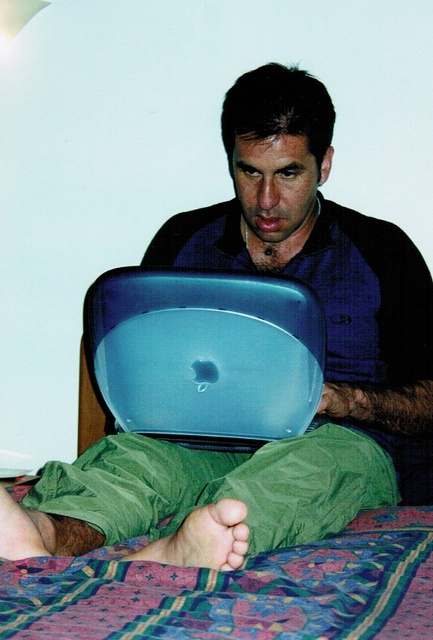Describe the objects in this image and their specific colors. I can see people in beige, black, green, and teal tones, bed in beige, teal, gray, and navy tones, and laptop in beige, teal, and lightblue tones in this image. 